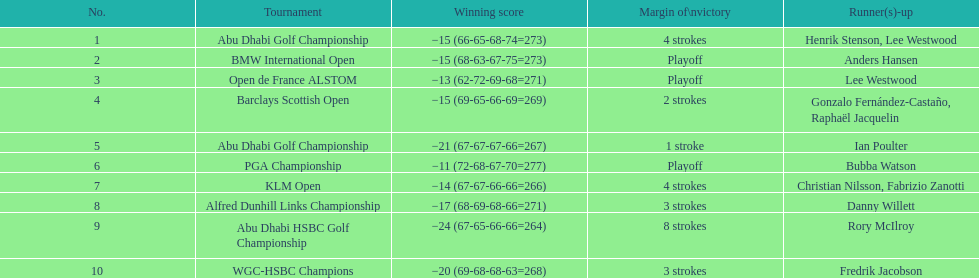Parse the table in full. {'header': ['No.', 'Tournament', 'Winning score', 'Margin of\\nvictory', 'Runner(s)-up'], 'rows': [['1', 'Abu Dhabi Golf Championship', '−15 (66-65-68-74=273)', '4 strokes', 'Henrik Stenson, Lee Westwood'], ['2', 'BMW International Open', '−15 (68-63-67-75=273)', 'Playoff', 'Anders Hansen'], ['3', 'Open de France ALSTOM', '−13 (62-72-69-68=271)', 'Playoff', 'Lee Westwood'], ['4', 'Barclays Scottish Open', '−15 (69-65-66-69=269)', '2 strokes', 'Gonzalo Fernández-Castaño, Raphaël Jacquelin'], ['5', 'Abu Dhabi Golf Championship', '−21 (67-67-67-66=267)', '1 stroke', 'Ian Poulter'], ['6', 'PGA Championship', '−11 (72-68-67-70=277)', 'Playoff', 'Bubba Watson'], ['7', 'KLM Open', '−14 (67-67-66-66=266)', '4 strokes', 'Christian Nilsson, Fabrizio Zanotti'], ['8', 'Alfred Dunhill Links Championship', '−17 (68-69-68-66=271)', '3 strokes', 'Danny Willett'], ['9', 'Abu Dhabi HSBC Golf Championship', '−24 (67-65-66-66=264)', '8 strokes', 'Rory McIlroy'], ['10', 'WGC-HSBC Champions', '−20 (69-68-68-63=268)', '3 strokes', 'Fredrik Jacobson']]} How many tournaments has he won by 3 or more strokes? 5. 